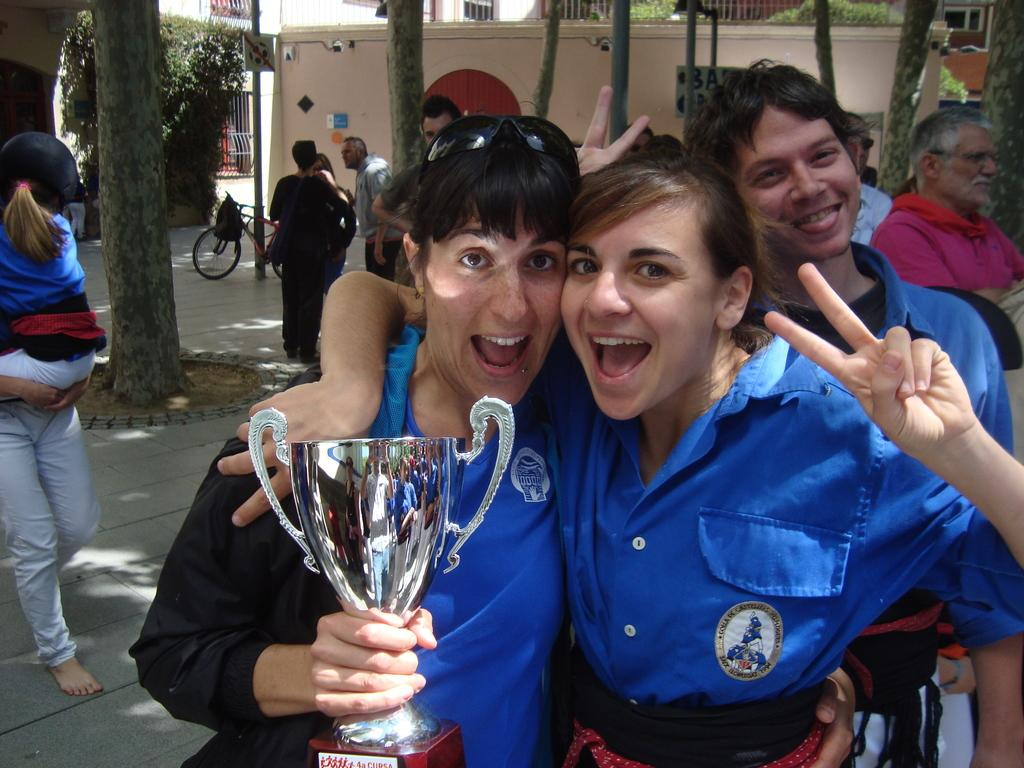How many people are in the image? There are people in the image, but the exact number is not specified. What is the person holding in the image? One person is holding a trophy in the image. What type of natural vegetation can be seen in the image? There are trees in the image. What type of man-made structures are visible in the image? There are buildings in the image. What type of barrier is present in the image? There is a railing in the image. What type of informational signs are present in the image? There are signboards in the image. What type of vertical structures are present in the image? There are poles in the image. What type of transportation is visible in the image? There is a bicycle in the image. What type of steel is used to construct the snake in the image? There is no snake present in the image, and therefore no steel construction can be observed. 